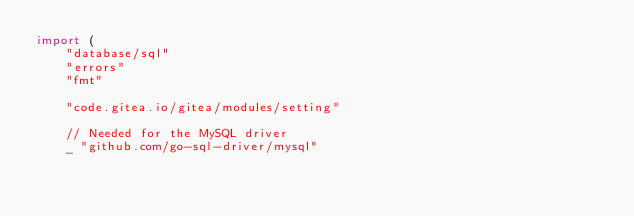<code> <loc_0><loc_0><loc_500><loc_500><_Go_>import (
	"database/sql"
	"errors"
	"fmt"

	"code.gitea.io/gitea/modules/setting"

	// Needed for the MySQL driver
	_ "github.com/go-sql-driver/mysql"</code> 